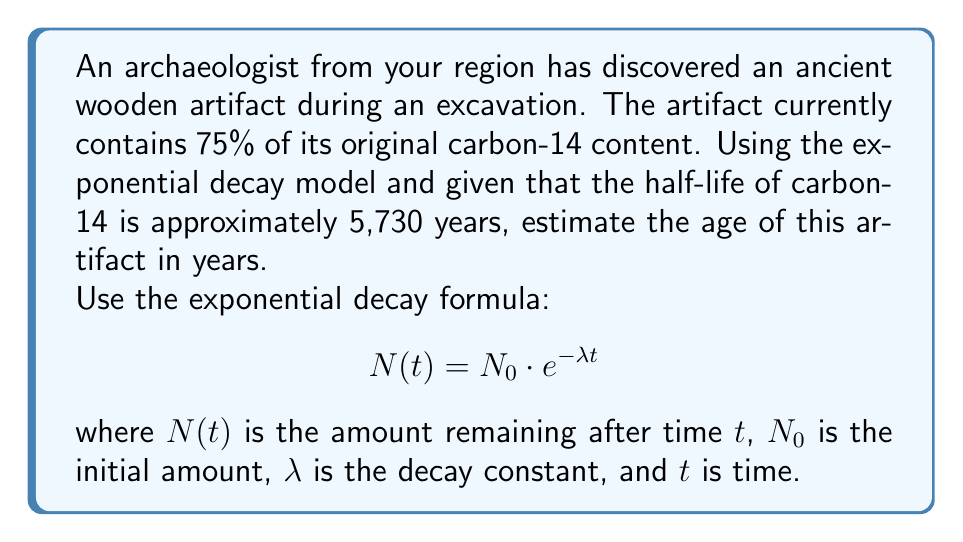Show me your answer to this math problem. To solve this problem, we'll follow these steps:

1) First, we need to calculate the decay constant $\lambda$ using the half-life.
   The half-life formula is: $T_{1/2} = \frac{\ln(2)}{\lambda}$
   
   Rearranging, we get: $\lambda = \frac{\ln(2)}{T_{1/2}} = \frac{\ln(2)}{5730} \approx 0.000121$ per year

2) Now, we can use the exponential decay formula:
   $$N(t) = N_0 \cdot e^{-\lambda t}$$

   We know that $N(t) = 75\% = 0.75$ of $N_0$, so:

   $$0.75 = e^{-0.000121t}$$

3) Taking natural logarithm of both sides:
   $$\ln(0.75) = -0.000121t$$

4) Solving for $t$:
   $$t = \frac{\ln(0.75)}{-0.000121} \approx 2385.4$$

Therefore, the estimated age of the artifact is approximately 2,385 years.
Answer: 2,385 years 